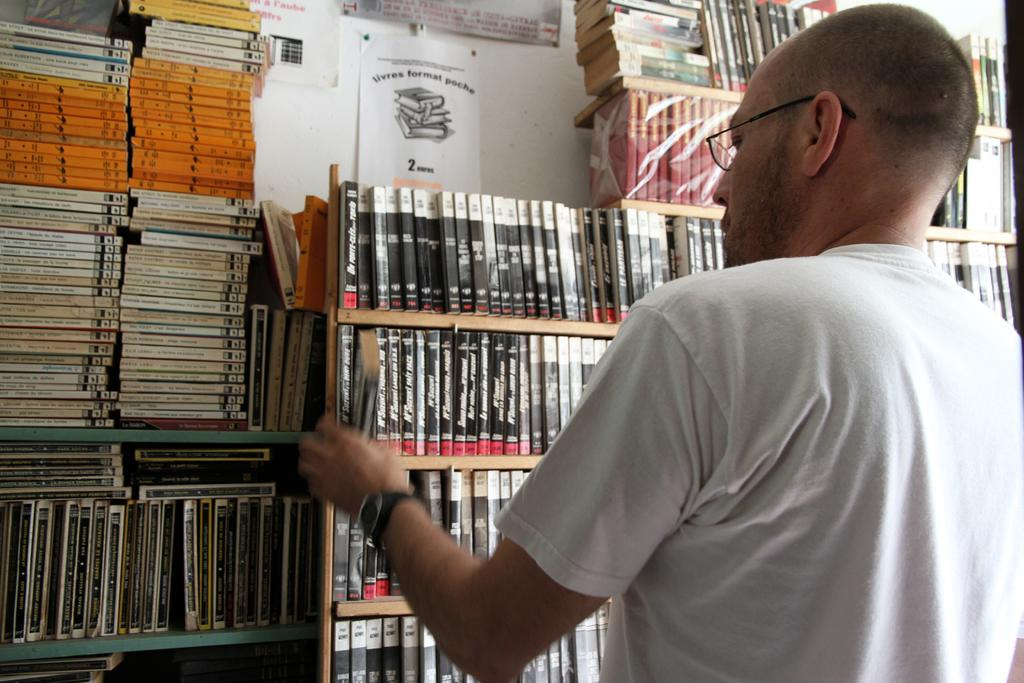<image>
Render a clear and concise summary of the photo. A man is browsing books in a library with a sign that has a 2 on it. 